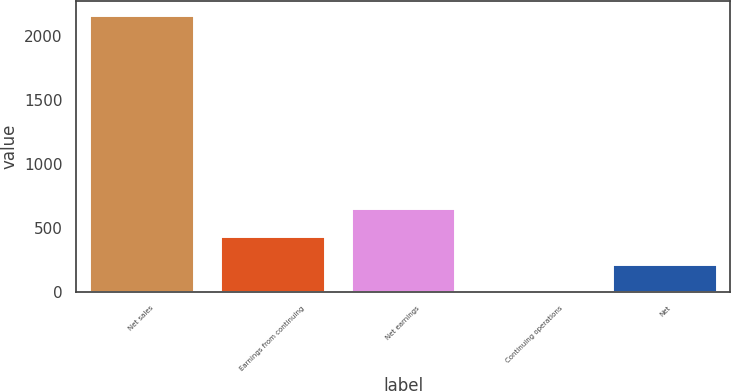<chart> <loc_0><loc_0><loc_500><loc_500><bar_chart><fcel>Net sales<fcel>Earnings from continuing<fcel>Net earnings<fcel>Continuing operations<fcel>Net<nl><fcel>2167.3<fcel>435.19<fcel>651.7<fcel>2.17<fcel>218.68<nl></chart> 